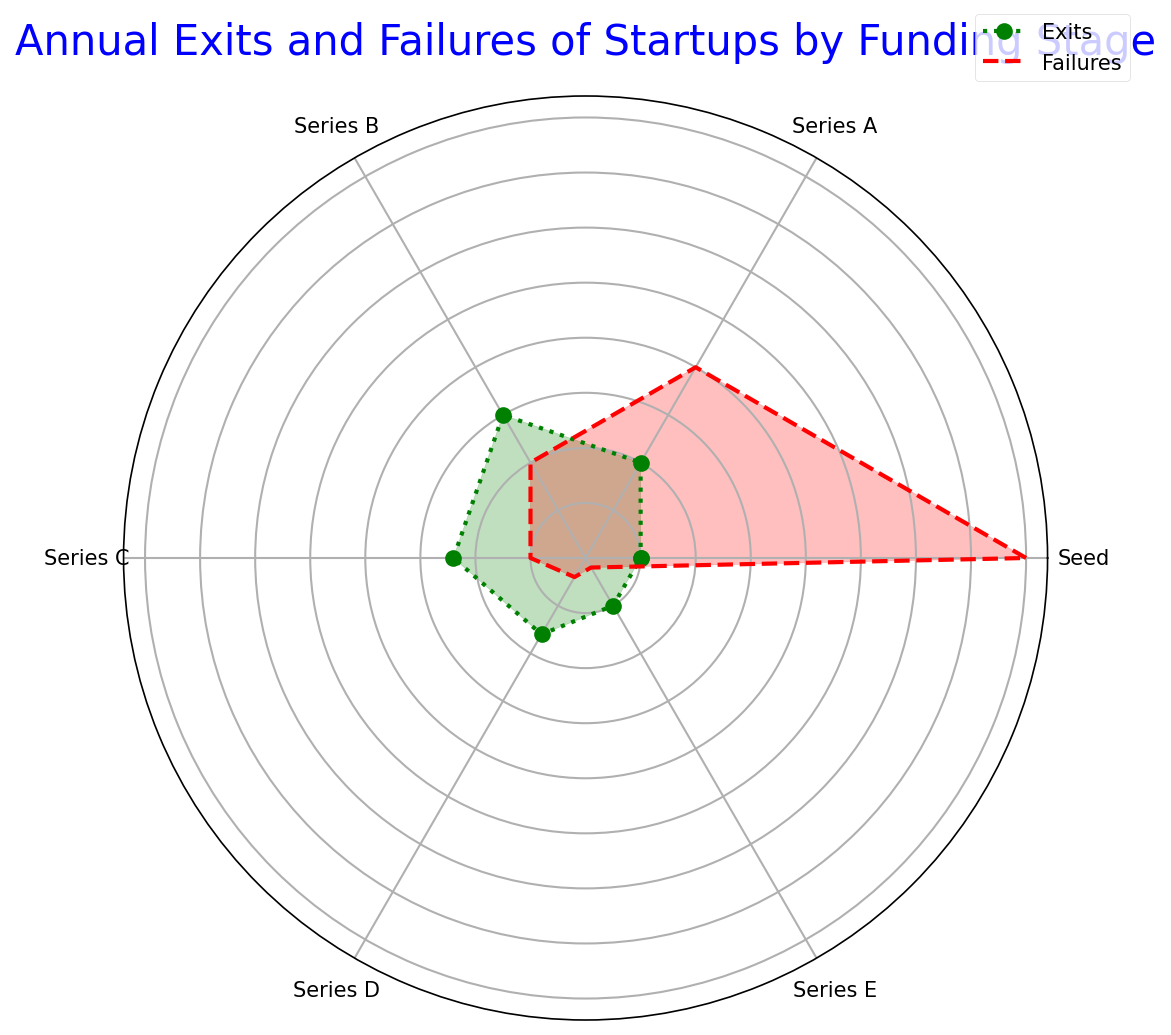What is the total number of exits from startups at the Series B stage? First, locate the "Exits" for the Series B stage, which is 15. Since there is only one data point for that stage, the total number of exits is simply 15.
Answer: 15 How many more failures are there at the Seed stage compared to the Series D stage? Locate the "Failures" values for both the Seed and Series D stages, which are 40 and 2, respectively. Calculate the difference: 40 - 2 = 38.
Answer: 38 Which stage has a higher number of exits, Series A or Series C? Compare the "Exits" for Series A and Series C, which are 10 and 12, respectively. The Series C stage has more exits.
Answer: Series C Among the stages presented, which one has the lowest number of failures? Look at all the "Failures" values: Seed (40), Series A (20), Series B (10), Series C (5), Series D (2), Series E (1). Series E has the lowest number of failures.
Answer: Series E How many total exits are there from all the funding stages combined? Add all the "Exits" values: 5 (Seed) + 10 (Series A) + 15 (Series B) + 12 (Series C) + 8 (Series D) + 5 (Series E) = 55.
Answer: 55 If you double the number of exits at the Seed stage, how many will there be? The "Exits" value at the Seed stage is 5. Doubling 5 results in 10.
Answer: 10 At which stage is the difference between exits and failures the greatest? Calculate the difference between "Exits" and "Failures" for each stage: Seed (40-5 = 35), Series A (20-10 = 10), Series B (10-15 = -5), Series C (5-12 = -7), Series D (2-8 = -6), Series E (1-5 = -4). The greatest difference is at the Seed stage (35).
Answer: Seed Which is more frequent: failures at the Series A stage or exits at the Seed stage? Compare "Failures" at Series A (20) with "Exits" at the Seed stage (5). Failures at the Series A stage are more frequent.
Answer: Failures at Series A What is the average number of failures across all funding stages? Sum the "Failures" values: 40 (Seed) + 20 (Series A) + 10 (Series B) + 5 (Series C) + 2 (Series D) + 1 (Series E) = 78. Divide by the number of stages (6): 78 / 6 = 13.
Answer: 13 